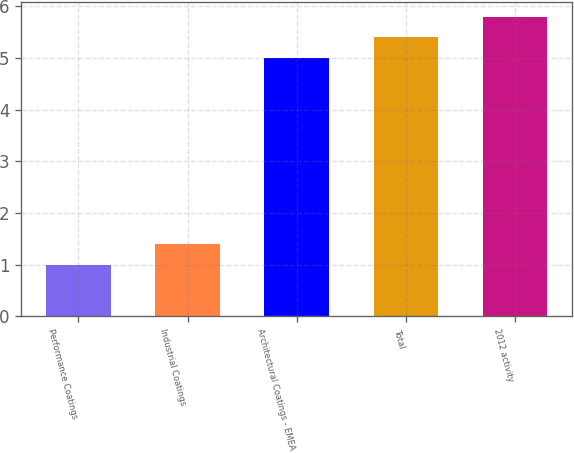Convert chart. <chart><loc_0><loc_0><loc_500><loc_500><bar_chart><fcel>Performance Coatings<fcel>Industrial Coatings<fcel>Architectural Coatings - EMEA<fcel>Total<fcel>2012 activity<nl><fcel>1<fcel>1.4<fcel>5<fcel>5.4<fcel>5.8<nl></chart> 